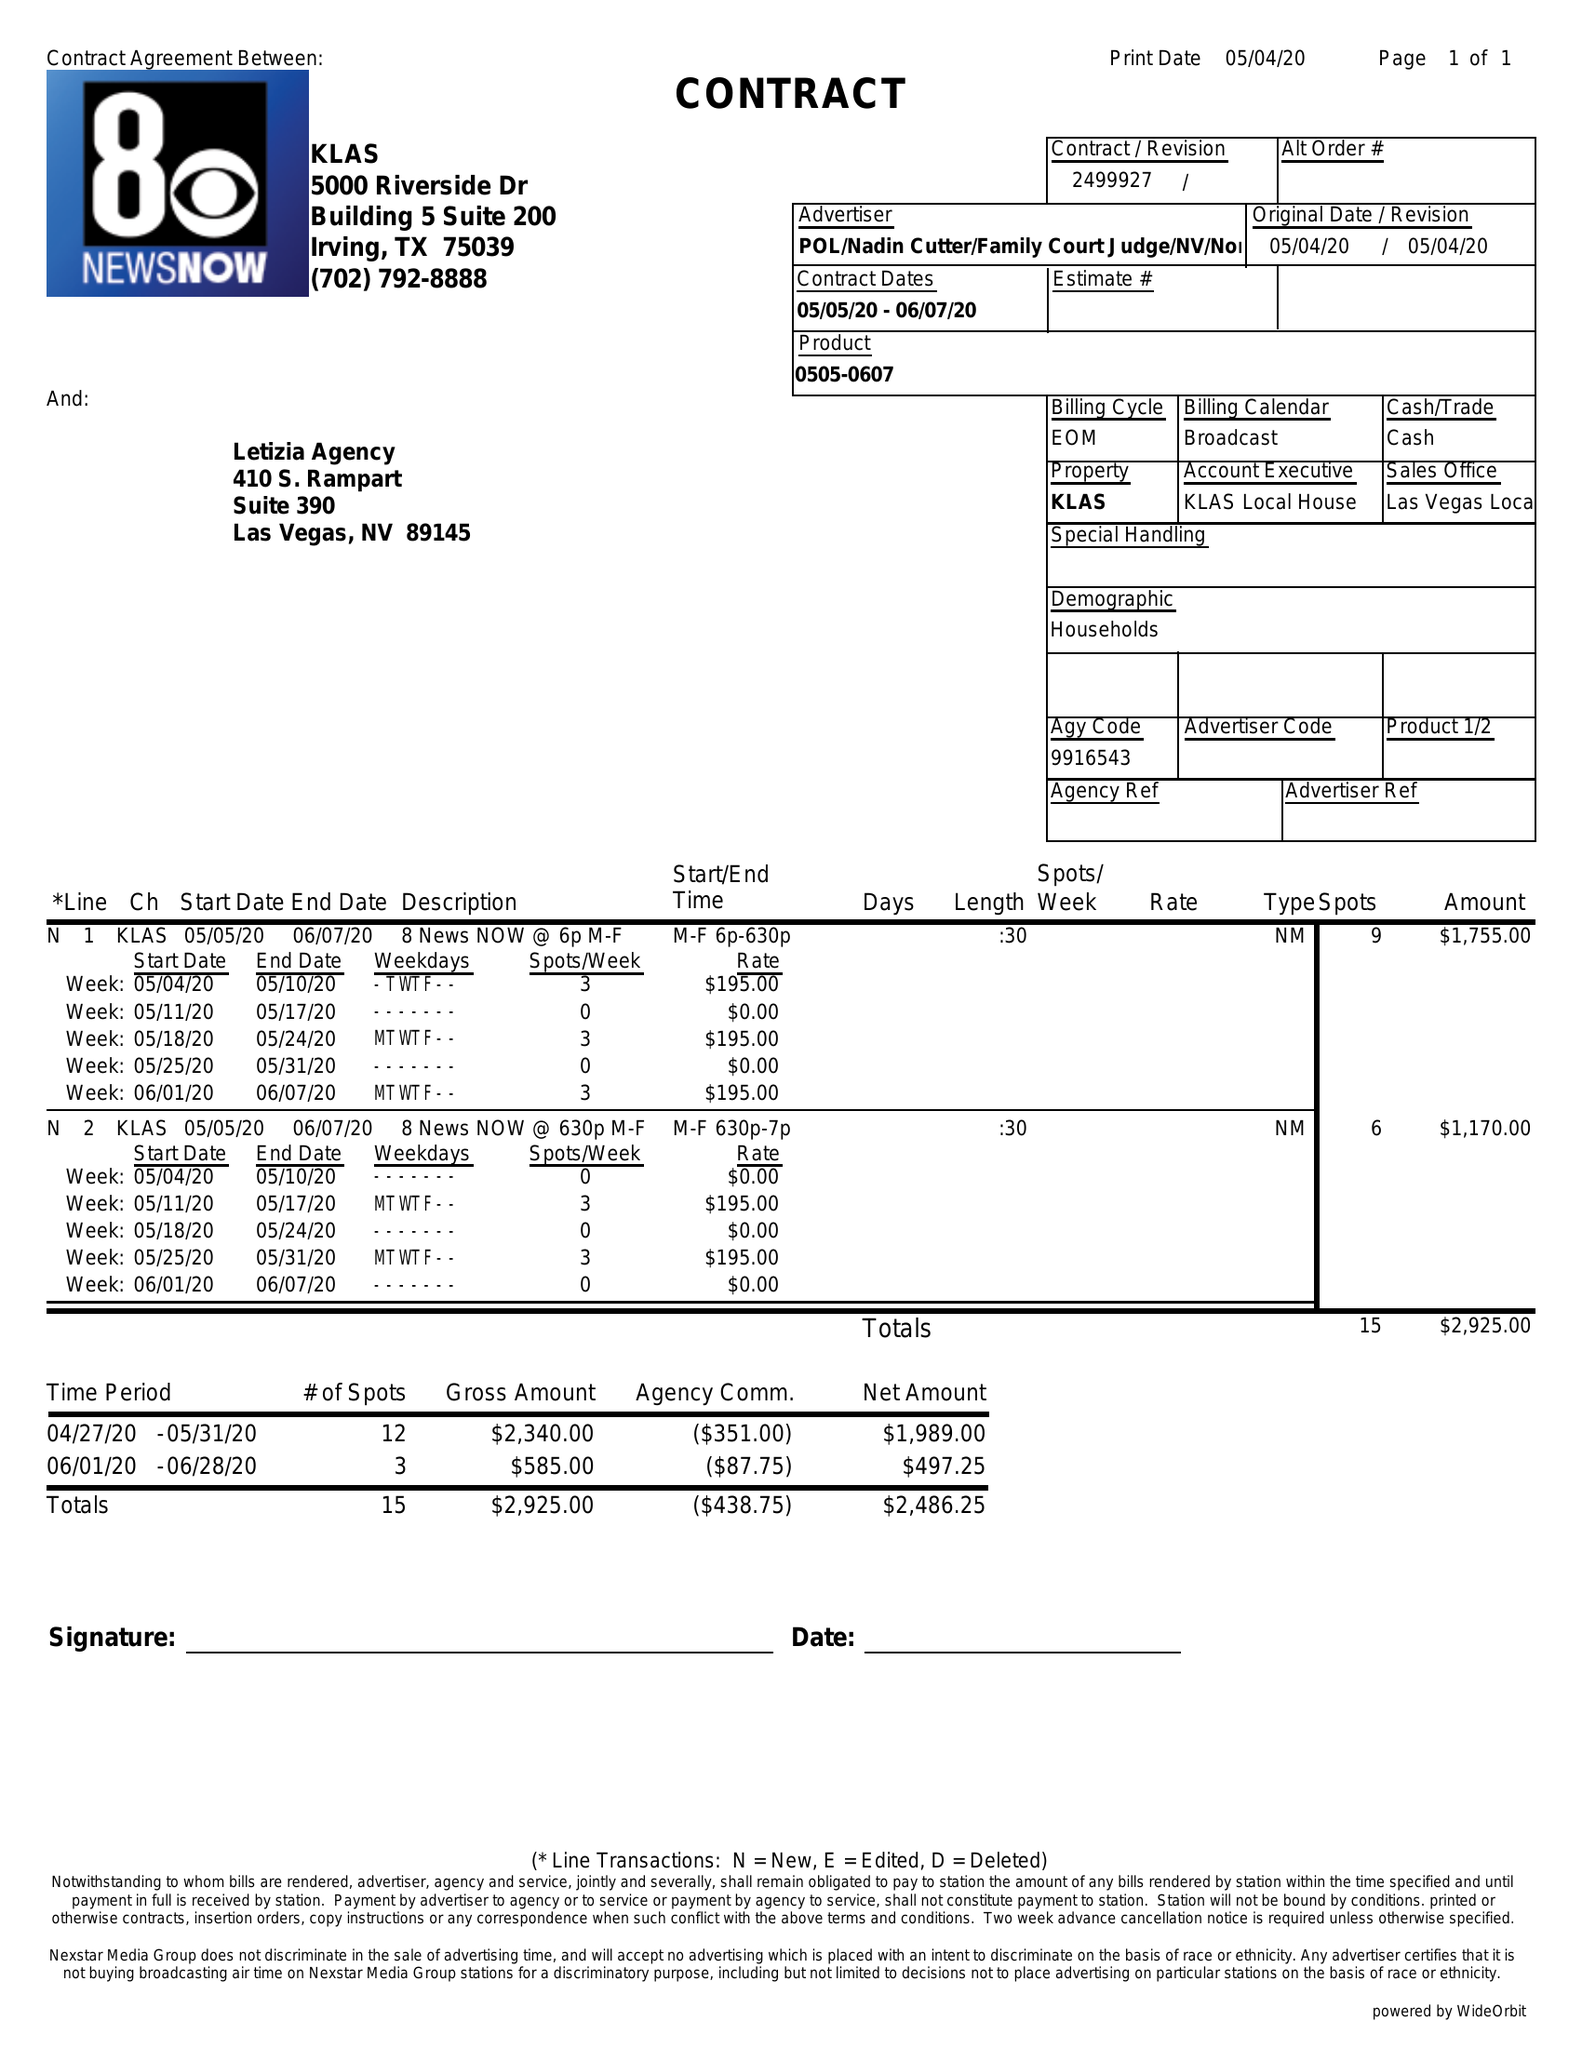What is the value for the advertiser?
Answer the question using a single word or phrase. POL/NADINCUTTER/FAMILYCOURTJUDGE/NV/NONPART 